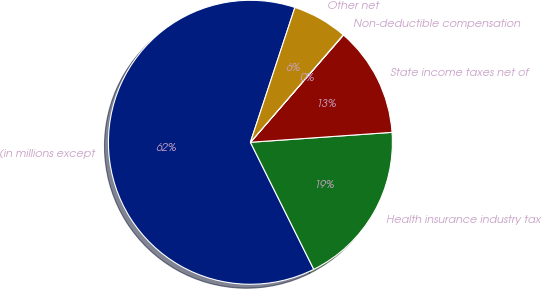Convert chart to OTSL. <chart><loc_0><loc_0><loc_500><loc_500><pie_chart><fcel>(in millions except<fcel>Health insurance industry tax<fcel>State income taxes net of<fcel>Non-deductible compensation<fcel>Other net<nl><fcel>62.43%<fcel>18.75%<fcel>12.51%<fcel>0.03%<fcel>6.27%<nl></chart> 